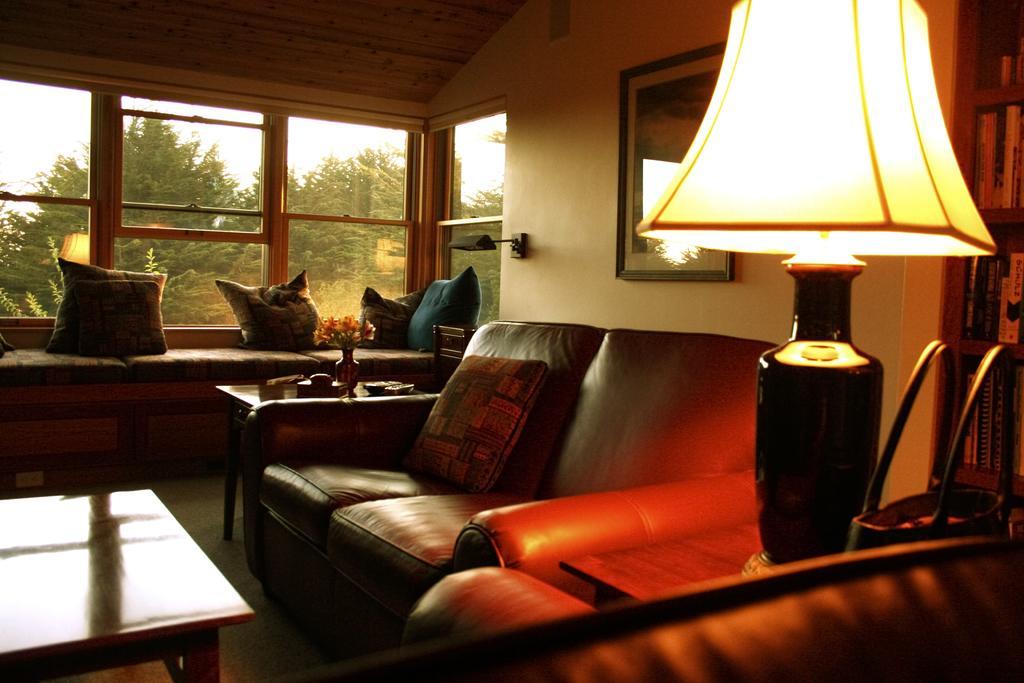Describe this image in one or two sentences. This is a picture of a hall in a house. In the foreground of the picture there is a couch. On the right there is a table ,on the table there is a lamp and a handbag. To the right there is closet and books. On the left there is a table. In the center of the picture there is a couch and a frame. On the left there is another couch and pillows and table, on the table there are few objects. In the background there is a window, through the window we can see trees and sky. 